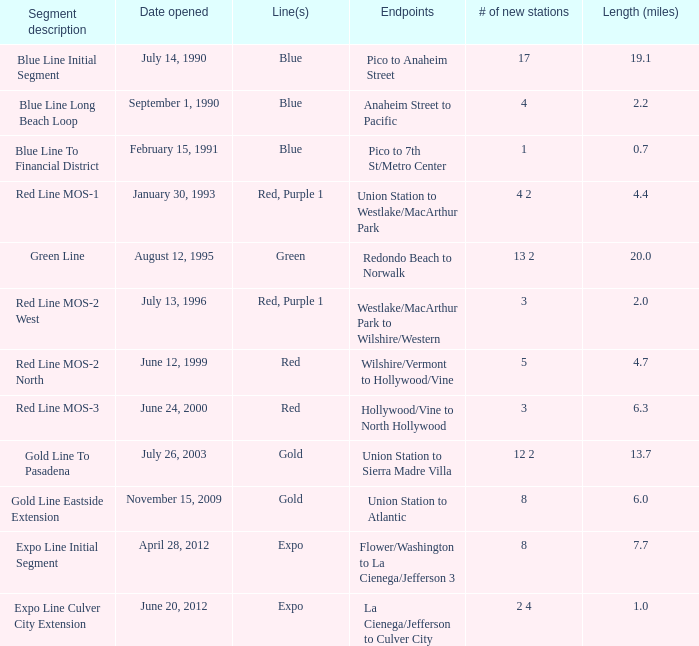How many lines have the segment description of red line mos-2 west? Red, Purple 1. 